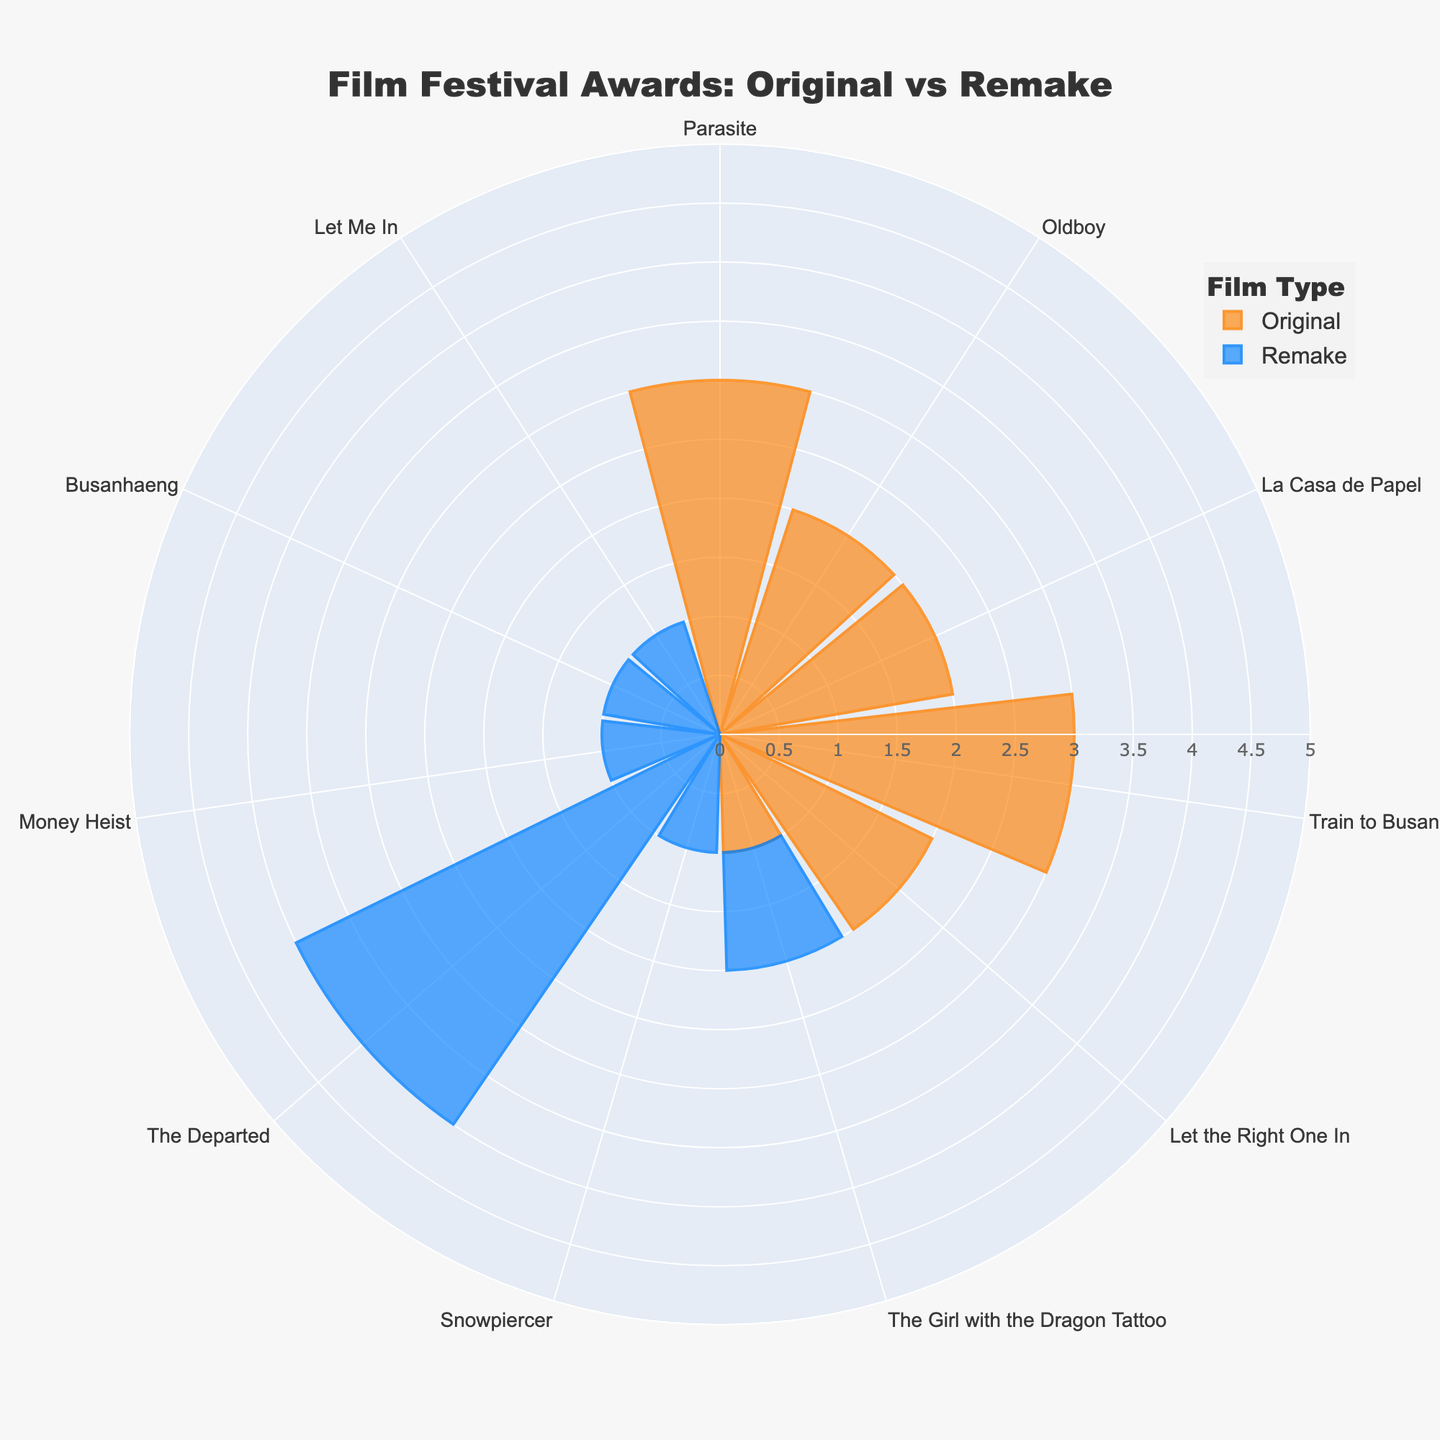What's the title of the figure? The title of the figure is displayed prominently at the top. It helps understand the subject of the chart.
Answer: Film Festival Awards: Original vs Remake What is the color representation of Original films on the chart? The chart uses different colors for Original and Remake films to differentiate them. The color representation for Original films is visible through the chart elements.
Answer: Orange Which film has won the most awards among the remakes? By observing the radial lengths in the Remake section, it's clear which bar extends the furthest, indicating the film with the most awards among remakes.
Answer: The Departed How many awards did "Parasite" win? The polar area chart shows the number of awards each film won. By locating Parasite in the chart, it's easy to count the number of segments or check the radial length.
Answer: 3 Which original film has won the least awards? The chart shows the awards won by each Original film. The film with the shortest bar among the Originals has the least awards.
Answer: The Girl with the Dragon Tattoo What is the total number of awards won by all remade films? Sum up the awards from all the bars representing remade films. These are The Departed (4), Money Heist (1), Let Me In (1), The Girl with the Dragon Tattoo (1), Snowpiercer (1), and Busanhaeng (1). The computation is 4 + 1 + 1 + 1 + 1 + 1.
Answer: 9 How do the awards won by original films at Sundance compare to those at Berlinale? Look at the radial lengths of the bars corresponding to the festivals for Original films. Compare the number of awards won by Let the Right One In (Sundance) and The Girl with the Dragon Tattoo (Berlinale).
Answer: More at Sundance What are the awards won differences between the original and remake of "The Girl with the Dragon Tattoo"? Compare the radial lengths of the original and remake versions of the film. The original won 1 award while the remake also won 1 award, resulting in a difference.
Answer: 0 How many films in total are depicted in the chart? Count the total number of individual bars for both Original and Remake films in the radial chart.
Answer: 12 Which film has the highest number of awards among all films? Identify the longest radial bar across both Original and Remake film sections. The film with the highest value is the one with the most awards.
Answer: The Departed 